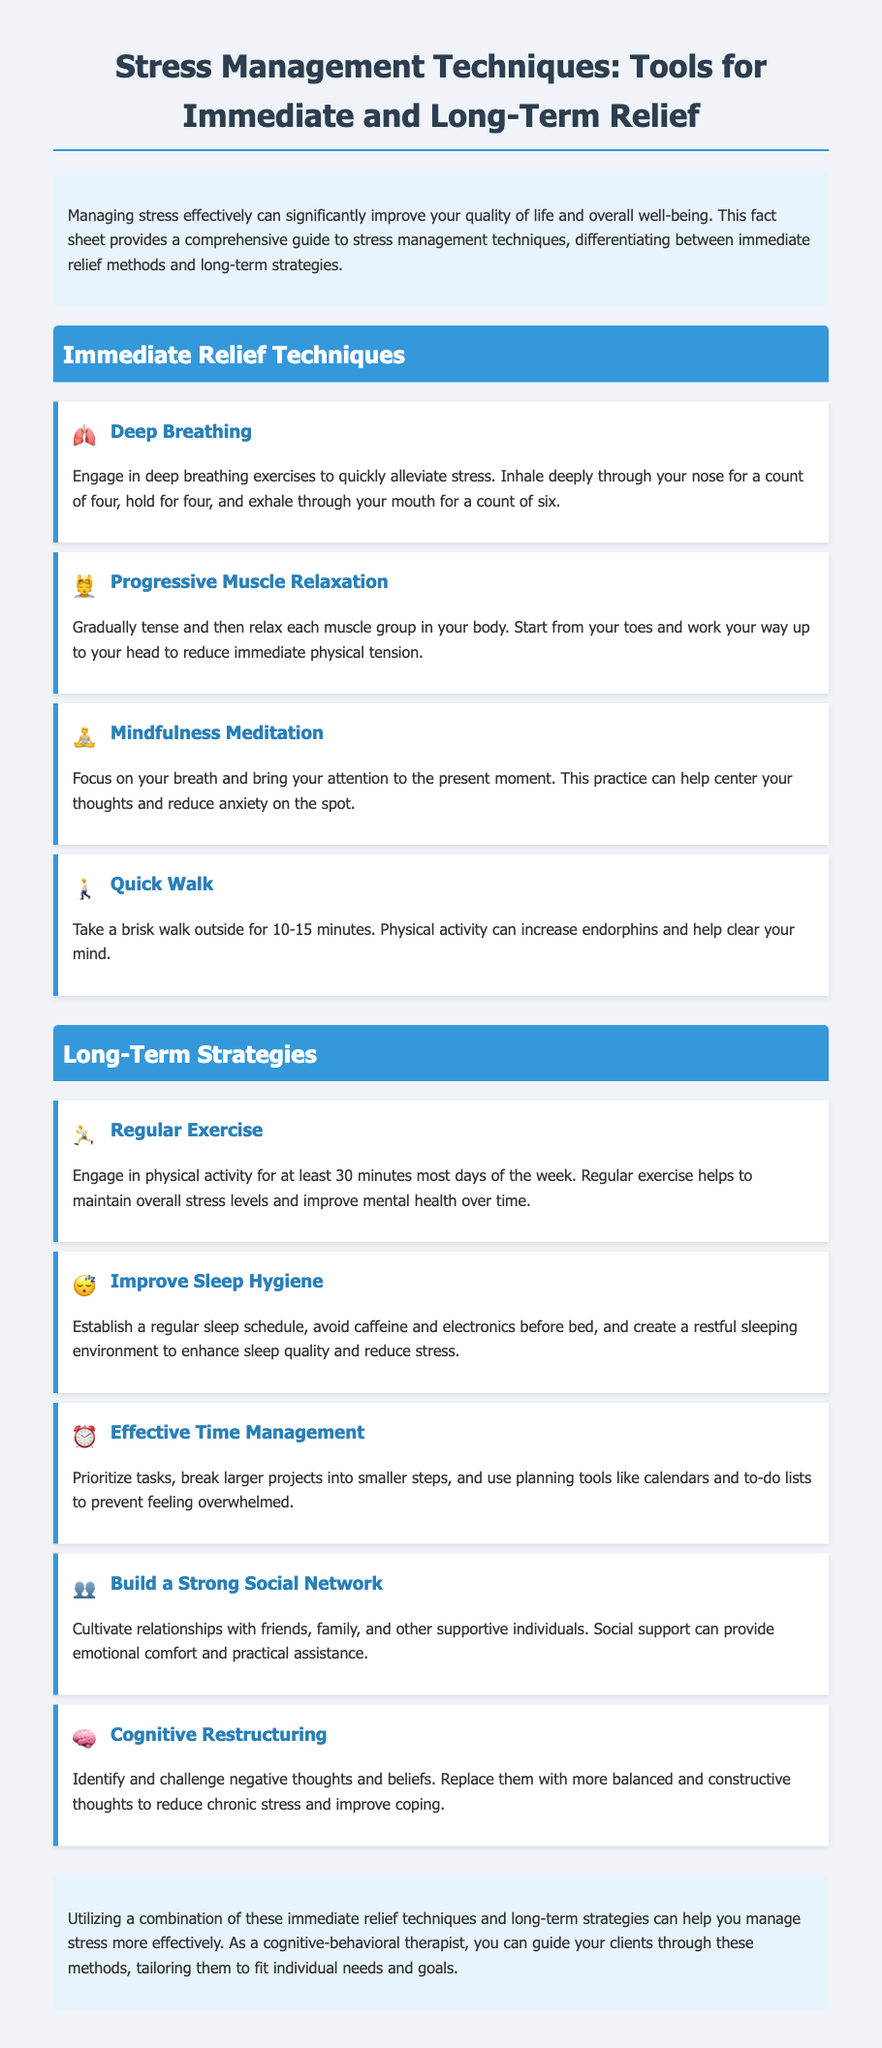what is the title of the document? The title is prominently displayed at the top of the document, summarizing its main focus.
Answer: Stress Management Techniques: Tools for Immediate and Long-Term Relief how many immediate relief techniques are listed? The document includes a section outlining immediate relief techniques, specifically indicating a count.
Answer: 4 what icon represents Deep Breathing? Each technique in the document has a corresponding icon to visually aid identification.
Answer: 🫁 what long-term strategy involves enhancing sleep quality? The long-term strategies section includes multiple techniques, one of which focuses on improving sleep.
Answer: Improve Sleep Hygiene which technique helps with prioritizing tasks? This technique is listed under long-term strategies, specifically focusing on organization.
Answer: Effective Time Management what is the primary benefit of regular exercise? The document outlines benefits associated with long-term strategies, including the particular advantages of exercise.
Answer: Improve mental health what symbol represents building a social network? Each technique has a specific icon that relates to its meaning, including the one for social connection.
Answer: 👥 what does cognitive restructuring aim to reduce? Cognitive restructuring is mentioned in context with its objective related to managing thoughts and stress.
Answer: Chronic stress 